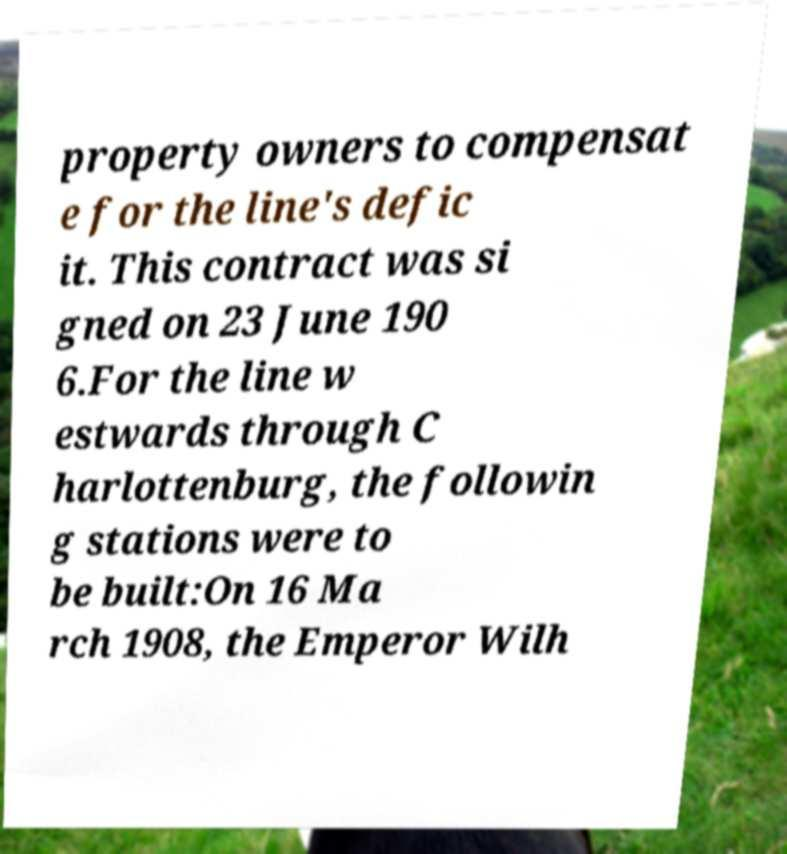Can you read and provide the text displayed in the image?This photo seems to have some interesting text. Can you extract and type it out for me? property owners to compensat e for the line's defic it. This contract was si gned on 23 June 190 6.For the line w estwards through C harlottenburg, the followin g stations were to be built:On 16 Ma rch 1908, the Emperor Wilh 